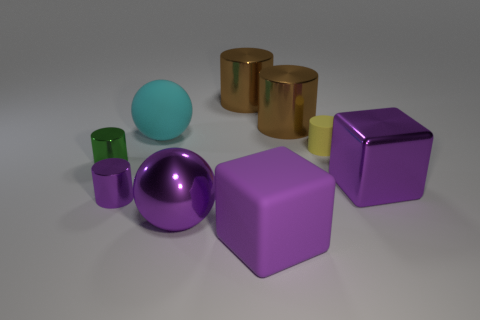What material is the purple cylinder that is the same size as the yellow thing?
Give a very brief answer. Metal. The large ball that is in front of the green object that is in front of the tiny cylinder behind the small green shiny cylinder is made of what material?
Provide a short and direct response. Metal. Are the small purple object and the small thing that is right of the big cyan object made of the same material?
Provide a succinct answer. No. What material is the green thing that is the same shape as the tiny purple thing?
Keep it short and to the point. Metal. What shape is the tiny metal thing on the left side of the small purple metal thing?
Give a very brief answer. Cylinder. The tiny matte cylinder has what color?
Keep it short and to the point. Yellow. How many other things are there of the same size as the matte cylinder?
Make the answer very short. 2. There is a sphere that is to the left of the big sphere in front of the large cyan rubber thing; what is it made of?
Keep it short and to the point. Rubber. Does the purple matte block have the same size as the green cylinder behind the big purple ball?
Offer a terse response. No. Is there a tiny cylinder of the same color as the big metal cube?
Offer a terse response. Yes. 